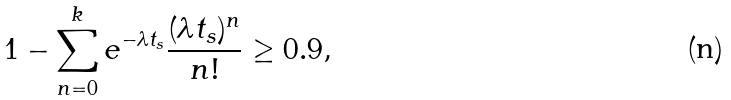<formula> <loc_0><loc_0><loc_500><loc_500>1 - \sum _ { n = 0 } ^ { k } e ^ { - \lambda t _ { s } } \frac { ( \lambda t _ { s } ) ^ { n } } { n ! } \geq 0 . 9 ,</formula> 